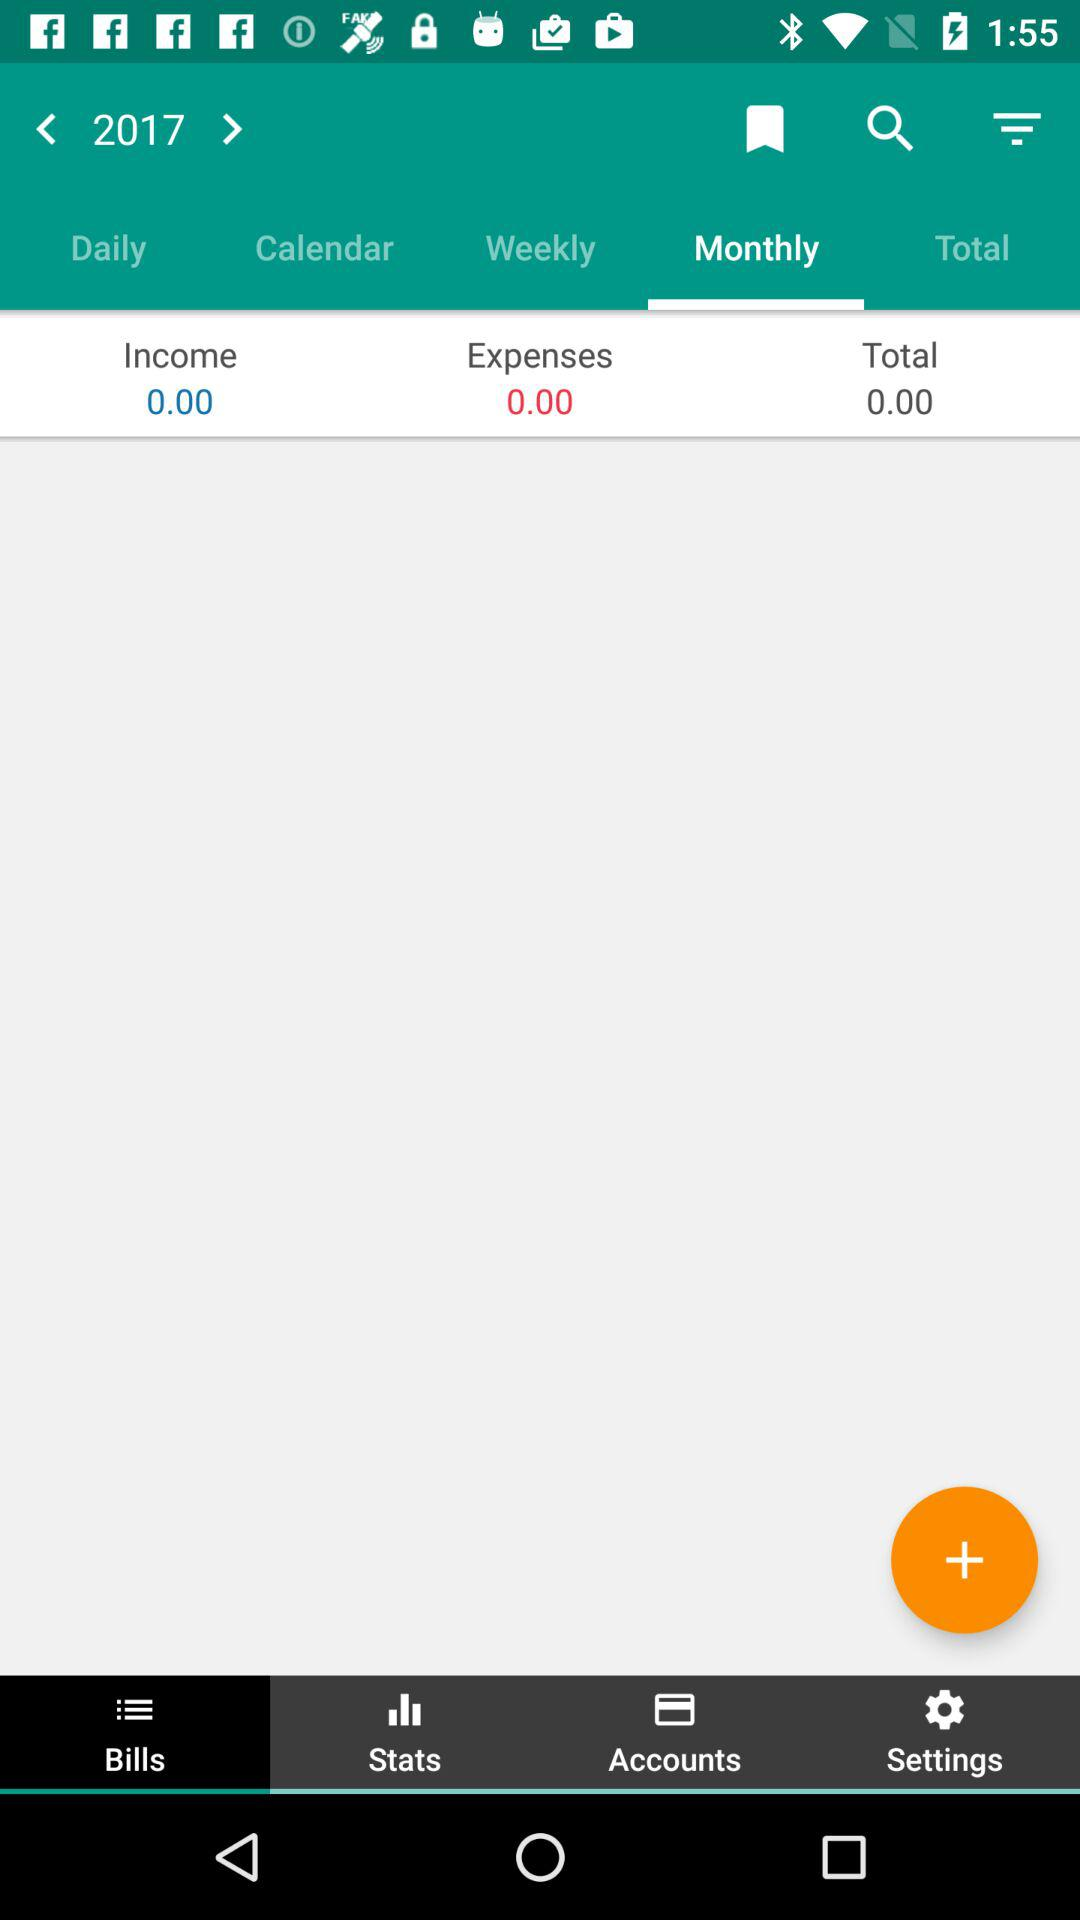Which tab has been selected? The selected tabs are "Monthly" and "Bills". 